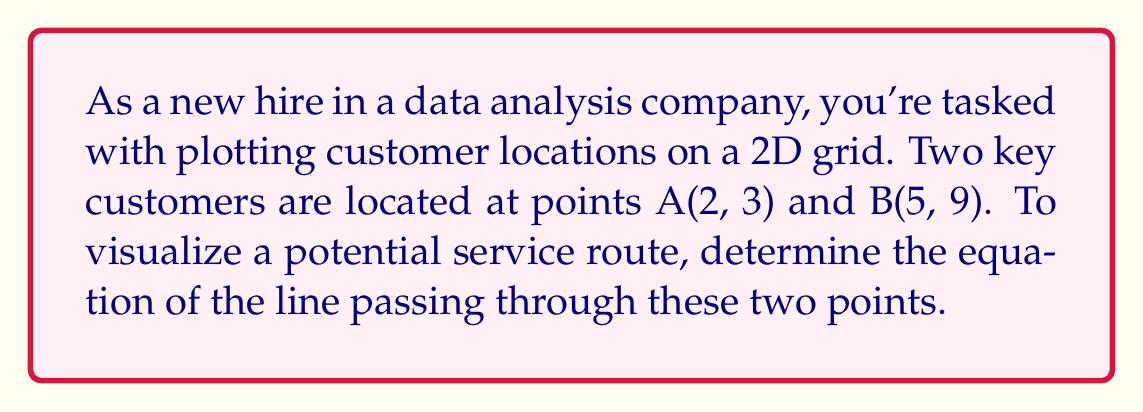Could you help me with this problem? Let's approach this step-by-step:

1) To find the equation of a line passing through two points, we can use the point-slope form:

   $y - y_1 = m(x - x_1)$

   where $m$ is the slope of the line, and $(x_1, y_1)$ is a point on the line.

2) First, we need to calculate the slope $m$. The slope formula is:

   $m = \frac{y_2 - y_1}{x_2 - x_1}$

3) Using the given points A(2, 3) and B(5, 9):

   $m = \frac{9 - 3}{5 - 2} = \frac{6}{3} = 2$

4) Now that we have the slope, we can use either point to write the equation. Let's use A(2, 3):

   $y - 3 = 2(x - 2)$

5) This is the point-slope form. To convert it to slope-intercept form $(y = mx + b)$, we expand:

   $y - 3 = 2x - 4$
   $y = 2x - 4 + 3$
   $y = 2x - 1$

6) Therefore, the equation of the line passing through A(2, 3) and B(5, 9) is $y = 2x - 1$.

To verify, we can plug in both points:
For A(2, 3): $3 = 2(2) - 1$, which is true.
For B(5, 9): $9 = 2(5) - 1$, which is also true.
Answer: $y = 2x - 1$ 